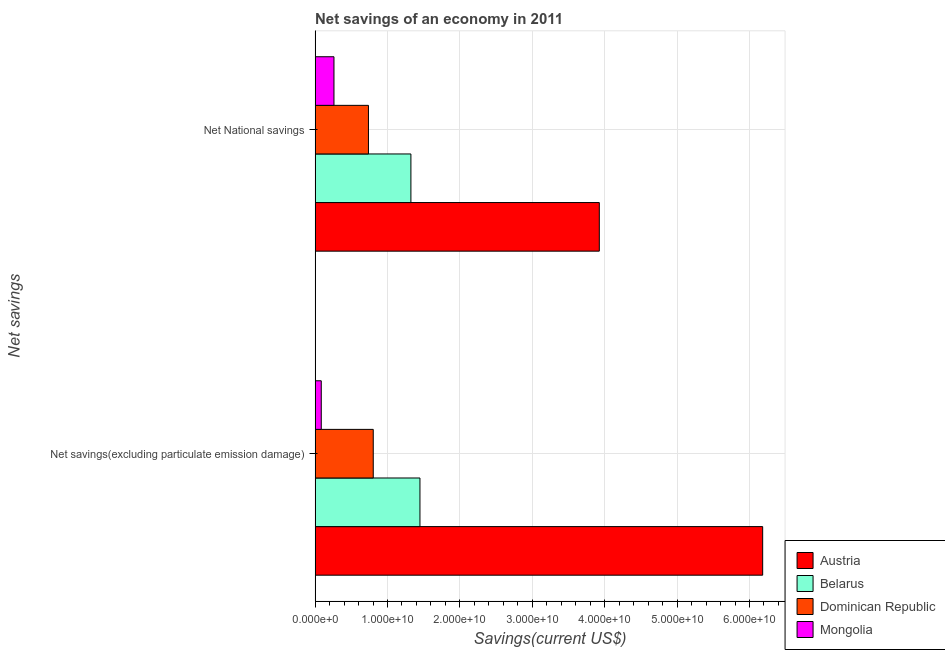How many groups of bars are there?
Provide a succinct answer. 2. Are the number of bars per tick equal to the number of legend labels?
Offer a very short reply. Yes. How many bars are there on the 2nd tick from the top?
Your answer should be compact. 4. What is the label of the 1st group of bars from the top?
Your response must be concise. Net National savings. What is the net savings(excluding particulate emission damage) in Austria?
Provide a short and direct response. 6.18e+1. Across all countries, what is the maximum net national savings?
Offer a very short reply. 3.93e+1. Across all countries, what is the minimum net savings(excluding particulate emission damage)?
Give a very brief answer. 8.50e+08. In which country was the net savings(excluding particulate emission damage) minimum?
Your answer should be very brief. Mongolia. What is the total net savings(excluding particulate emission damage) in the graph?
Ensure brevity in your answer.  8.52e+1. What is the difference between the net savings(excluding particulate emission damage) in Belarus and that in Mongolia?
Your answer should be compact. 1.36e+1. What is the difference between the net national savings in Mongolia and the net savings(excluding particulate emission damage) in Dominican Republic?
Make the answer very short. -5.43e+09. What is the average net national savings per country?
Provide a short and direct response. 1.56e+1. What is the difference between the net savings(excluding particulate emission damage) and net national savings in Belarus?
Your answer should be very brief. 1.25e+09. What is the ratio of the net savings(excluding particulate emission damage) in Belarus to that in Dominican Republic?
Offer a very short reply. 1.8. Is the net national savings in Dominican Republic less than that in Belarus?
Your answer should be compact. Yes. In how many countries, is the net savings(excluding particulate emission damage) greater than the average net savings(excluding particulate emission damage) taken over all countries?
Your answer should be compact. 1. What does the 2nd bar from the bottom in Net savings(excluding particulate emission damage) represents?
Offer a terse response. Belarus. How many bars are there?
Your answer should be compact. 8. Are all the bars in the graph horizontal?
Your response must be concise. Yes. How many countries are there in the graph?
Your answer should be very brief. 4. What is the difference between two consecutive major ticks on the X-axis?
Your answer should be very brief. 1.00e+1. Are the values on the major ticks of X-axis written in scientific E-notation?
Provide a short and direct response. Yes. How many legend labels are there?
Offer a terse response. 4. How are the legend labels stacked?
Offer a very short reply. Vertical. What is the title of the graph?
Offer a very short reply. Net savings of an economy in 2011. What is the label or title of the X-axis?
Keep it short and to the point. Savings(current US$). What is the label or title of the Y-axis?
Ensure brevity in your answer.  Net savings. What is the Savings(current US$) in Austria in Net savings(excluding particulate emission damage)?
Offer a terse response. 6.18e+1. What is the Savings(current US$) in Belarus in Net savings(excluding particulate emission damage)?
Your answer should be compact. 1.45e+1. What is the Savings(current US$) of Dominican Republic in Net savings(excluding particulate emission damage)?
Your answer should be very brief. 8.03e+09. What is the Savings(current US$) in Mongolia in Net savings(excluding particulate emission damage)?
Keep it short and to the point. 8.50e+08. What is the Savings(current US$) of Austria in Net National savings?
Offer a terse response. 3.93e+1. What is the Savings(current US$) of Belarus in Net National savings?
Give a very brief answer. 1.32e+1. What is the Savings(current US$) of Dominican Republic in Net National savings?
Your response must be concise. 7.37e+09. What is the Savings(current US$) in Mongolia in Net National savings?
Give a very brief answer. 2.61e+09. Across all Net savings, what is the maximum Savings(current US$) of Austria?
Provide a short and direct response. 6.18e+1. Across all Net savings, what is the maximum Savings(current US$) in Belarus?
Provide a short and direct response. 1.45e+1. Across all Net savings, what is the maximum Savings(current US$) of Dominican Republic?
Keep it short and to the point. 8.03e+09. Across all Net savings, what is the maximum Savings(current US$) in Mongolia?
Your answer should be very brief. 2.61e+09. Across all Net savings, what is the minimum Savings(current US$) of Austria?
Your answer should be very brief. 3.93e+1. Across all Net savings, what is the minimum Savings(current US$) in Belarus?
Provide a succinct answer. 1.32e+1. Across all Net savings, what is the minimum Savings(current US$) in Dominican Republic?
Provide a short and direct response. 7.37e+09. Across all Net savings, what is the minimum Savings(current US$) of Mongolia?
Keep it short and to the point. 8.50e+08. What is the total Savings(current US$) of Austria in the graph?
Give a very brief answer. 1.01e+11. What is the total Savings(current US$) in Belarus in the graph?
Provide a short and direct response. 2.77e+1. What is the total Savings(current US$) of Dominican Republic in the graph?
Your response must be concise. 1.54e+1. What is the total Savings(current US$) in Mongolia in the graph?
Ensure brevity in your answer.  3.46e+09. What is the difference between the Savings(current US$) of Austria in Net savings(excluding particulate emission damage) and that in Net National savings?
Your answer should be compact. 2.26e+1. What is the difference between the Savings(current US$) of Belarus in Net savings(excluding particulate emission damage) and that in Net National savings?
Provide a succinct answer. 1.25e+09. What is the difference between the Savings(current US$) in Dominican Republic in Net savings(excluding particulate emission damage) and that in Net National savings?
Provide a succinct answer. 6.63e+08. What is the difference between the Savings(current US$) in Mongolia in Net savings(excluding particulate emission damage) and that in Net National savings?
Your response must be concise. -1.76e+09. What is the difference between the Savings(current US$) of Austria in Net savings(excluding particulate emission damage) and the Savings(current US$) of Belarus in Net National savings?
Provide a short and direct response. 4.86e+1. What is the difference between the Savings(current US$) of Austria in Net savings(excluding particulate emission damage) and the Savings(current US$) of Dominican Republic in Net National savings?
Your answer should be very brief. 5.45e+1. What is the difference between the Savings(current US$) in Austria in Net savings(excluding particulate emission damage) and the Savings(current US$) in Mongolia in Net National savings?
Ensure brevity in your answer.  5.92e+1. What is the difference between the Savings(current US$) in Belarus in Net savings(excluding particulate emission damage) and the Savings(current US$) in Dominican Republic in Net National savings?
Provide a succinct answer. 7.11e+09. What is the difference between the Savings(current US$) in Belarus in Net savings(excluding particulate emission damage) and the Savings(current US$) in Mongolia in Net National savings?
Offer a terse response. 1.19e+1. What is the difference between the Savings(current US$) in Dominican Republic in Net savings(excluding particulate emission damage) and the Savings(current US$) in Mongolia in Net National savings?
Provide a succinct answer. 5.43e+09. What is the average Savings(current US$) of Austria per Net savings?
Keep it short and to the point. 5.05e+1. What is the average Savings(current US$) in Belarus per Net savings?
Give a very brief answer. 1.39e+1. What is the average Savings(current US$) of Dominican Republic per Net savings?
Provide a short and direct response. 7.70e+09. What is the average Savings(current US$) of Mongolia per Net savings?
Offer a very short reply. 1.73e+09. What is the difference between the Savings(current US$) in Austria and Savings(current US$) in Belarus in Net savings(excluding particulate emission damage)?
Provide a short and direct response. 4.73e+1. What is the difference between the Savings(current US$) in Austria and Savings(current US$) in Dominican Republic in Net savings(excluding particulate emission damage)?
Offer a very short reply. 5.38e+1. What is the difference between the Savings(current US$) of Austria and Savings(current US$) of Mongolia in Net savings(excluding particulate emission damage)?
Make the answer very short. 6.10e+1. What is the difference between the Savings(current US$) of Belarus and Savings(current US$) of Dominican Republic in Net savings(excluding particulate emission damage)?
Ensure brevity in your answer.  6.45e+09. What is the difference between the Savings(current US$) in Belarus and Savings(current US$) in Mongolia in Net savings(excluding particulate emission damage)?
Offer a very short reply. 1.36e+1. What is the difference between the Savings(current US$) of Dominican Republic and Savings(current US$) of Mongolia in Net savings(excluding particulate emission damage)?
Keep it short and to the point. 7.18e+09. What is the difference between the Savings(current US$) of Austria and Savings(current US$) of Belarus in Net National savings?
Keep it short and to the point. 2.60e+1. What is the difference between the Savings(current US$) in Austria and Savings(current US$) in Dominican Republic in Net National savings?
Provide a succinct answer. 3.19e+1. What is the difference between the Savings(current US$) in Austria and Savings(current US$) in Mongolia in Net National savings?
Offer a terse response. 3.67e+1. What is the difference between the Savings(current US$) in Belarus and Savings(current US$) in Dominican Republic in Net National savings?
Your answer should be very brief. 5.86e+09. What is the difference between the Savings(current US$) of Belarus and Savings(current US$) of Mongolia in Net National savings?
Keep it short and to the point. 1.06e+1. What is the difference between the Savings(current US$) in Dominican Republic and Savings(current US$) in Mongolia in Net National savings?
Make the answer very short. 4.76e+09. What is the ratio of the Savings(current US$) in Austria in Net savings(excluding particulate emission damage) to that in Net National savings?
Give a very brief answer. 1.57. What is the ratio of the Savings(current US$) in Belarus in Net savings(excluding particulate emission damage) to that in Net National savings?
Give a very brief answer. 1.09. What is the ratio of the Savings(current US$) in Dominican Republic in Net savings(excluding particulate emission damage) to that in Net National savings?
Give a very brief answer. 1.09. What is the ratio of the Savings(current US$) of Mongolia in Net savings(excluding particulate emission damage) to that in Net National savings?
Ensure brevity in your answer.  0.33. What is the difference between the highest and the second highest Savings(current US$) of Austria?
Give a very brief answer. 2.26e+1. What is the difference between the highest and the second highest Savings(current US$) of Belarus?
Your answer should be compact. 1.25e+09. What is the difference between the highest and the second highest Savings(current US$) in Dominican Republic?
Your answer should be compact. 6.63e+08. What is the difference between the highest and the second highest Savings(current US$) in Mongolia?
Give a very brief answer. 1.76e+09. What is the difference between the highest and the lowest Savings(current US$) in Austria?
Keep it short and to the point. 2.26e+1. What is the difference between the highest and the lowest Savings(current US$) in Belarus?
Keep it short and to the point. 1.25e+09. What is the difference between the highest and the lowest Savings(current US$) of Dominican Republic?
Your response must be concise. 6.63e+08. What is the difference between the highest and the lowest Savings(current US$) in Mongolia?
Your response must be concise. 1.76e+09. 